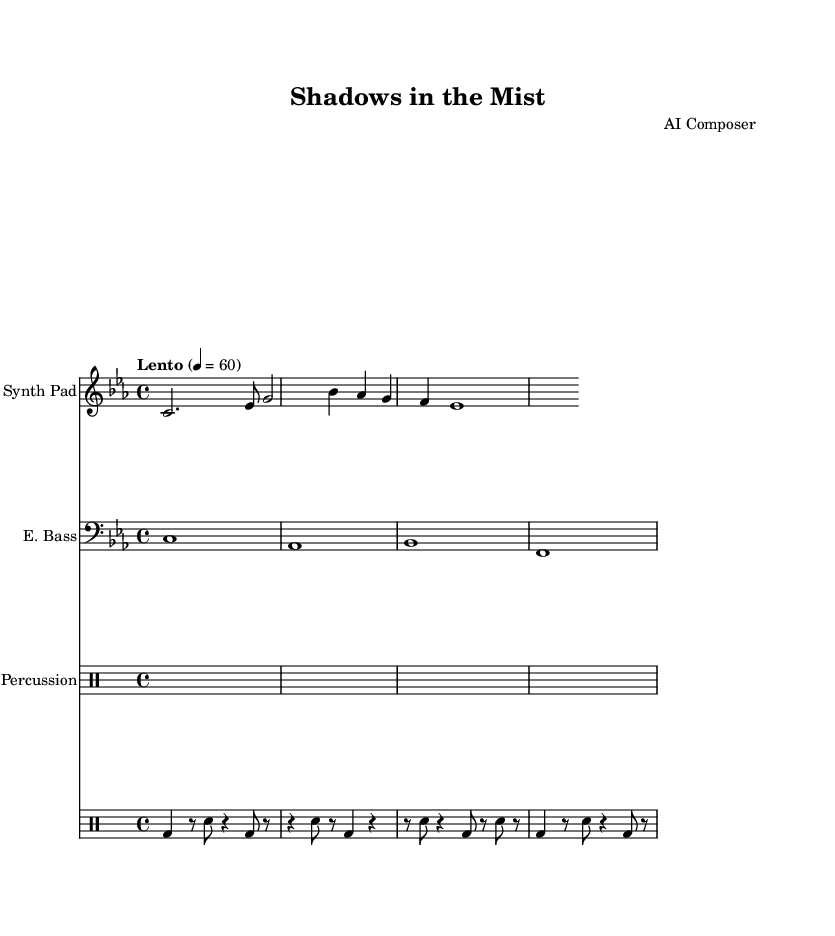what is the key signature of this music? The key signature is C minor, which has three flats: B flat, E flat, and A flat. You can identify the key signature by looking at the sharp or flat indicators at the beginning of the staff.
Answer: C minor what is the time signature of this piece? The time signature is 4/4, which is indicated at the beginning of the score. This means there are four beats in a measure, with the quarter note getting one beat.
Answer: 4/4 what is the tempo marking of this music? The tempo marking is "Lento," which indicates a slow pace. The specific BPM is set at 60 beats per minute, as indicated in the tempo marking.
Answer: Lento what instruments are used in this composition? The instruments used are a Synth Pad, Electronic Bass, and Percussion. This is indicated by the instrument names labeled above each staff in the score.
Answer: Synth Pad, Electronic Bass, Percussion how many measures are in the percussion part? The percussion part consists of four measures, which can be determined by counting the distinct groupings of beats and rests shown in the percussion staff. Each grouping corresponds to one measure.
Answer: 4 which instrument plays the highest pitch? The Synth Pad plays the highest pitch in this composition, as it is notated on the treble staff, which typically contains higher notes compared to the bass staff of the Electronic Bass and the lower ranges of the drums.
Answer: Synth Pad what rhythmic pattern is primarily used in the percussion? The percussion uses a combination of bass drum, snare drum, and rests, predominantly in eighth and quarter notes, creating a syncopated rhythm pattern that supports the atmospheric texture of the soundtrack.
Answer: Syncopated 